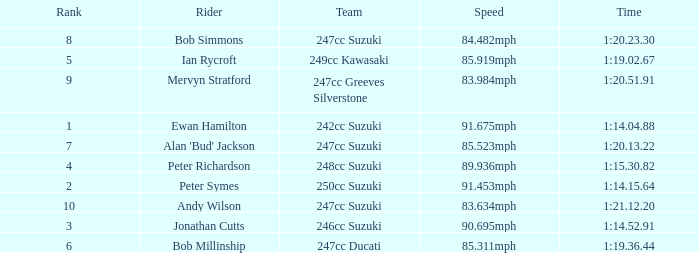Which team had a rank under 4 with a time of 1:14.04.88? 242cc Suzuki. 